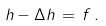Convert formula to latex. <formula><loc_0><loc_0><loc_500><loc_500>h - \Delta h \, = \, f \, .</formula> 